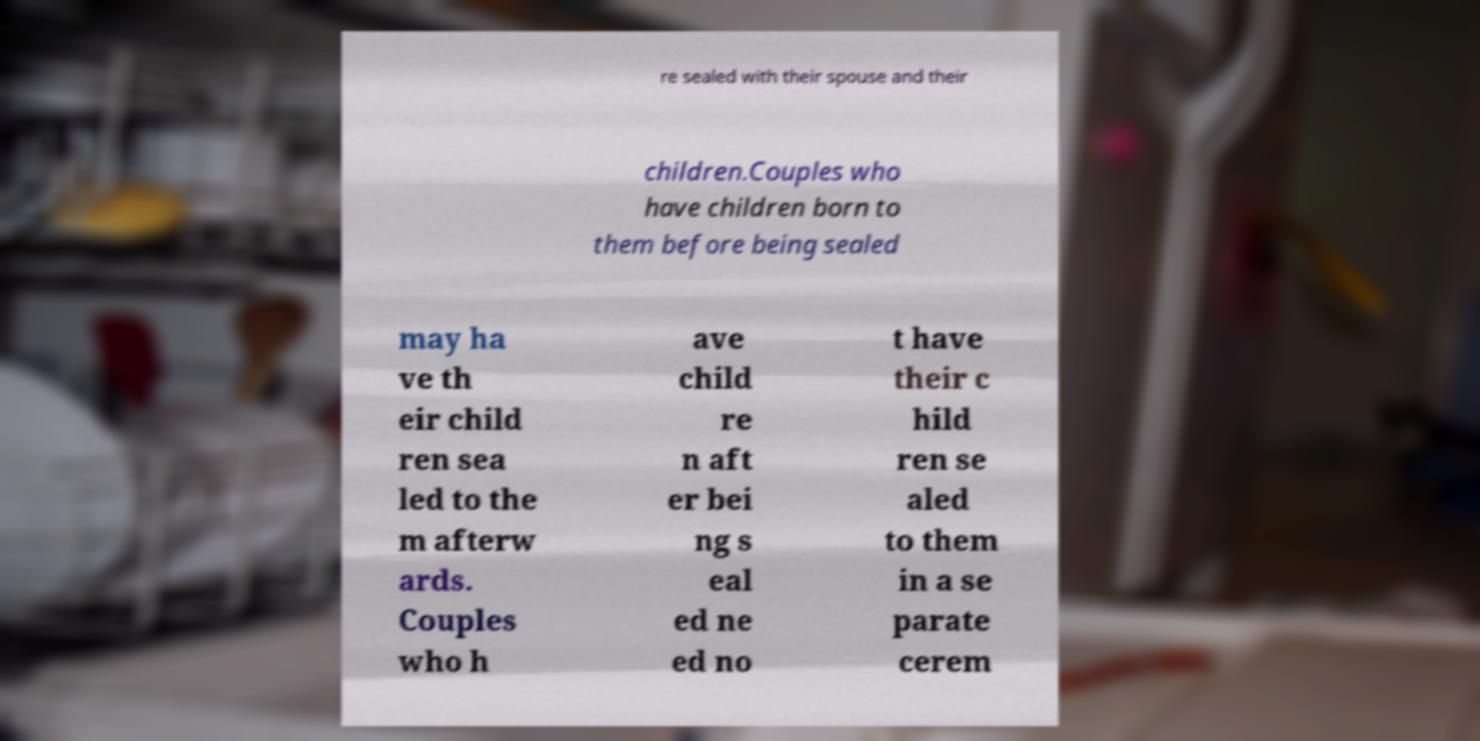Could you extract and type out the text from this image? re sealed with their spouse and their children.Couples who have children born to them before being sealed may ha ve th eir child ren sea led to the m afterw ards. Couples who h ave child re n aft er bei ng s eal ed ne ed no t have their c hild ren se aled to them in a se parate cerem 